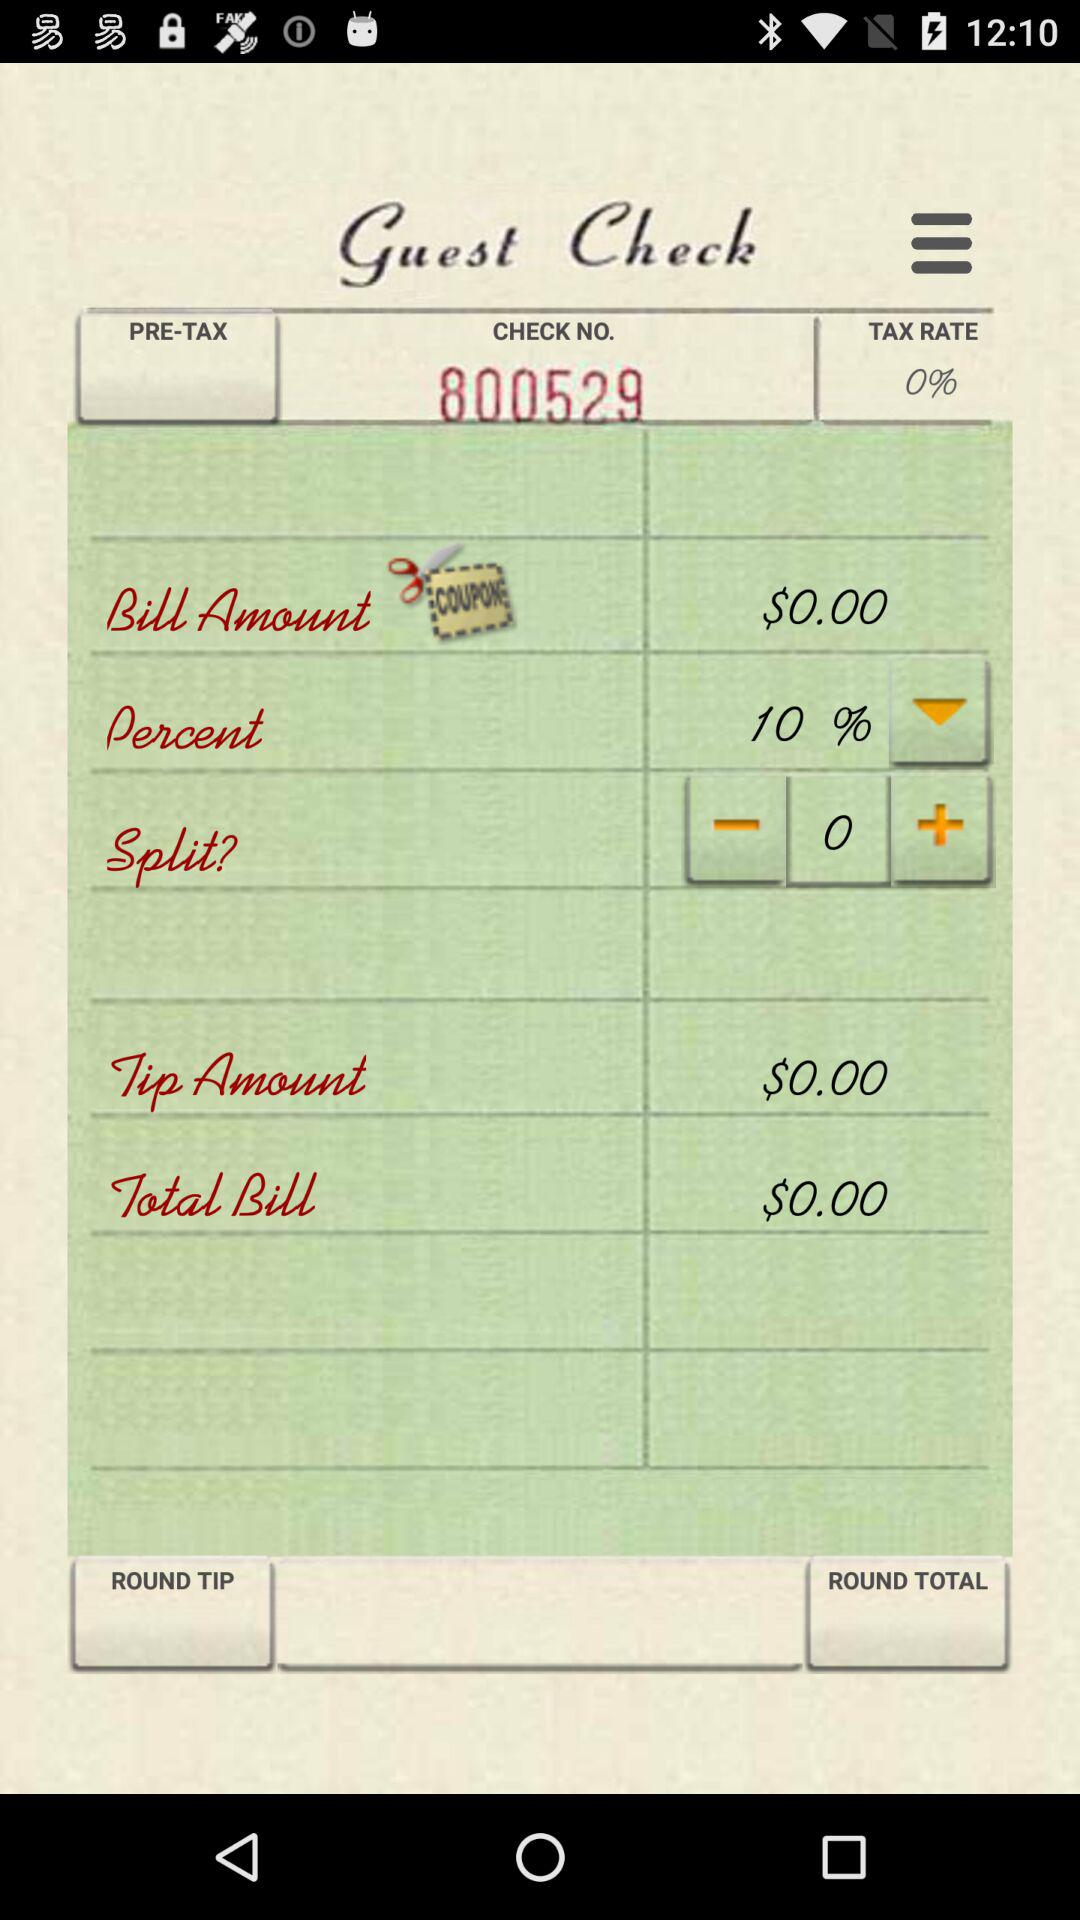What is the tax rate? The tax rate is 0%. 